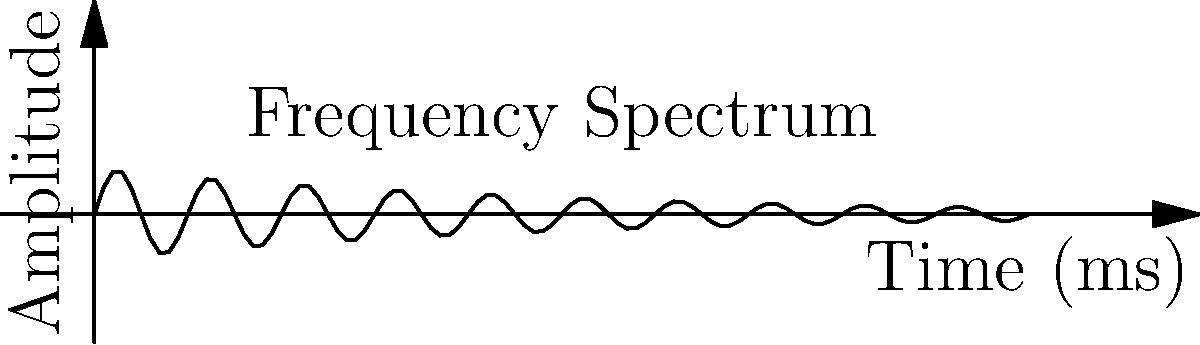In the frequency spectrum analysis of sonar imaging data from a submerged shipwreck, you observe a decaying sinusoidal pattern as shown in the graph. If the time scale is in milliseconds, what is the approximate frequency of the dominant signal in kHz? To determine the frequency of the dominant signal, we need to follow these steps:

1. Identify the period of the sinusoidal pattern:
   - Count the number of complete cycles in a given time interval
   - In this case, we can see approximately 5 complete cycles in 10 ms

2. Calculate the period (T):
   $T = \frac{10 \text{ ms}}{5 \text{ cycles}} = 2 \text{ ms/cycle}$

3. Convert the period to frequency (f):
   $f = \frac{1}{T} = \frac{1}{2 \text{ ms}} = 0.5 \text{ kHz}$

4. Verify the result:
   - The formula for frequency is $f = \frac{1}{T}$
   - Substituting our values: $f = \frac{1}{2 \times 10^{-3} \text{ s}} = 500 \text{ Hz} = 0.5 \text{ kHz}$

Therefore, the approximate frequency of the dominant signal is 0.5 kHz.
Answer: 0.5 kHz 